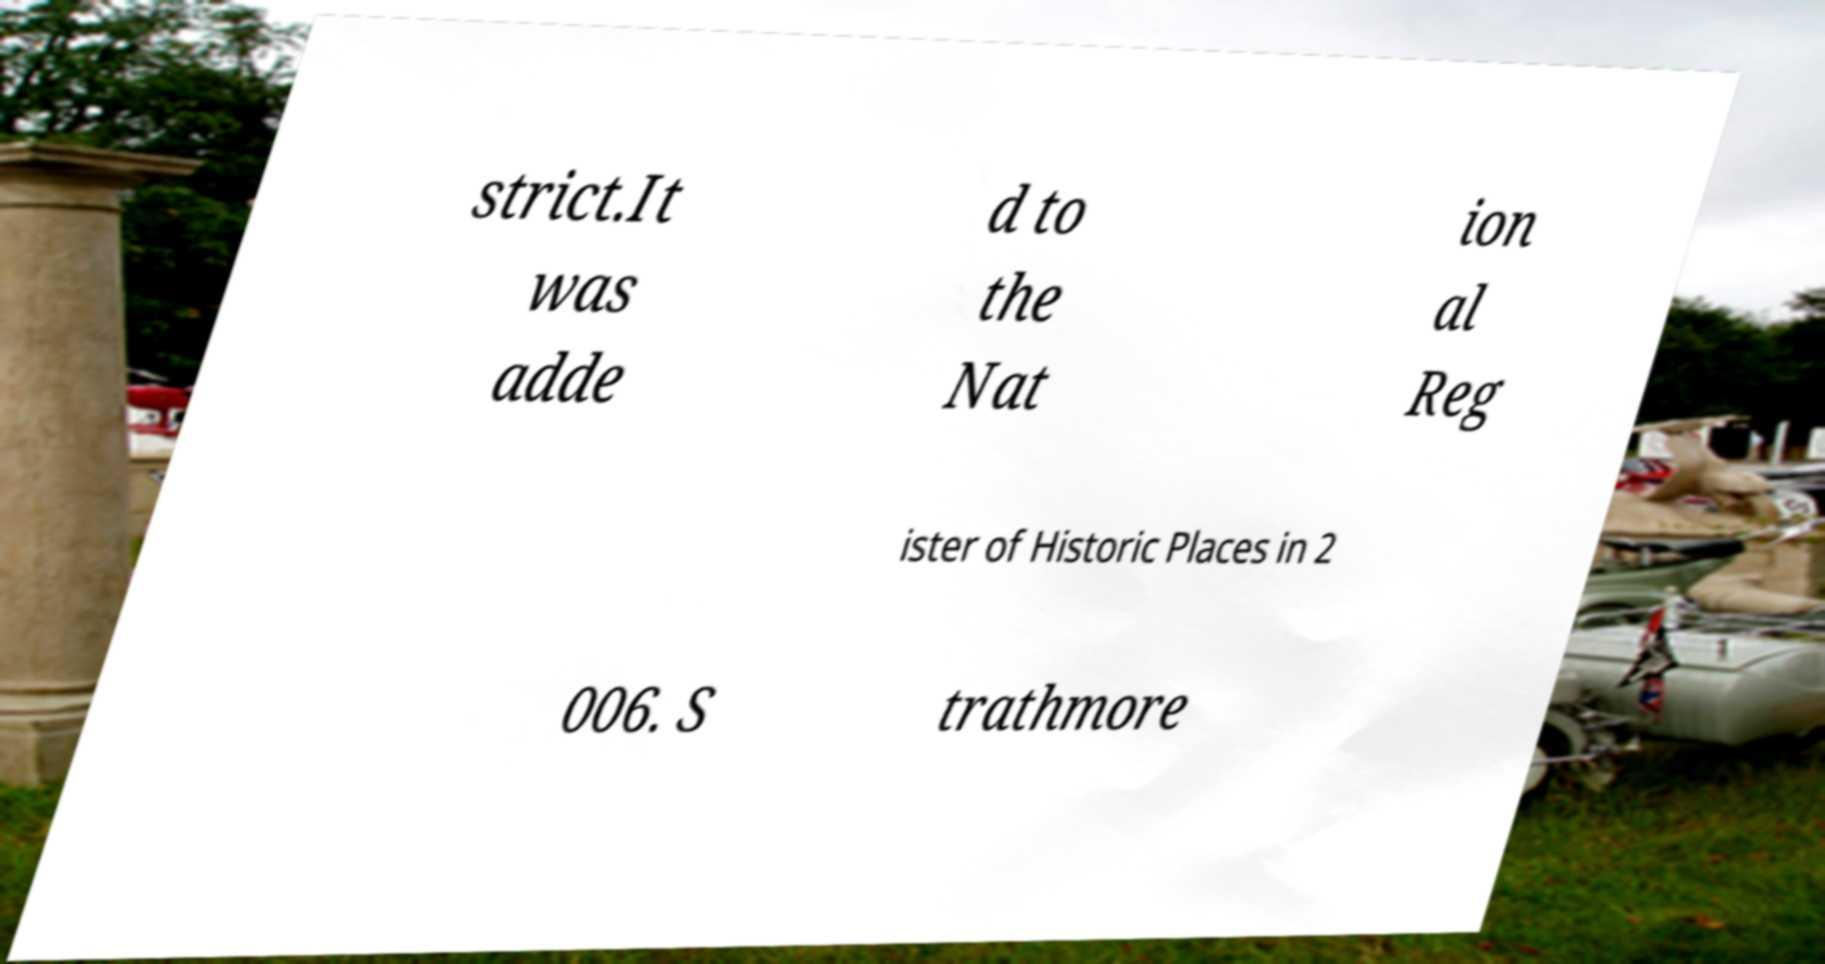I need the written content from this picture converted into text. Can you do that? strict.It was adde d to the Nat ion al Reg ister of Historic Places in 2 006. S trathmore 